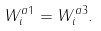<formula> <loc_0><loc_0><loc_500><loc_500>W _ { i } ^ { a 1 } = W _ { i } ^ { a 3 } .</formula> 